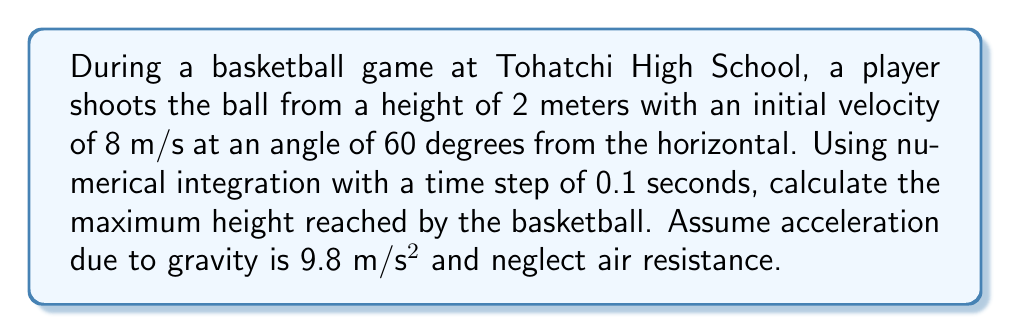Could you help me with this problem? To solve this problem, we'll use the Euler method for numerical integration. Let's break it down step-by-step:

1) First, let's define our initial conditions:
   - Initial height: $y_0 = 2$ m
   - Initial velocity in y-direction: $v_{y0} = 8 \sin(60°) = 6.93$ m/s
   - Acceleration due to gravity: $a = -9.8$ m/s²
   - Time step: $\Delta t = 0.1$ s

2) The Euler method gives us these equations:
   $y_{n+1} = y_n + v_n \Delta t$
   $v_{n+1} = v_n + a \Delta t$

3) We'll iterate until the velocity becomes negative, indicating the ball has reached its peak:

   Step 0: $t = 0$ s, $y = 2$ m, $v = 6.93$ m/s
   Step 1: $t = 0.1$ s
           $y_1 = 2 + 6.93 * 0.1 = 2.693$ m
           $v_1 = 6.93 + (-9.8) * 0.1 = 5.95$ m/s
   Step 2: $t = 0.2$ s
           $y_2 = 2.693 + 5.95 * 0.1 = 3.288$ m
           $v_2 = 5.95 + (-9.8) * 0.1 = 4.97$ m/s
   Step 3: $t = 0.3$ s
           $y_3 = 3.288 + 4.97 * 0.1 = 3.785$ m
           $v_3 = 4.97 + (-9.8) * 0.1 = 3.99$ m/s
   Step 4: $t = 0.4$ s
           $y_4 = 3.785 + 3.99 * 0.1 = 4.184$ m
           $v_4 = 3.99 + (-9.8) * 0.1 = 3.01$ m/s
   Step 5: $t = 0.5$ s
           $y_5 = 4.184 + 3.01 * 0.1 = 4.485$ m
           $v_5 = 3.01 + (-9.8) * 0.1 = 2.03$ m/s
   Step 6: $t = 0.6$ s
           $y_6 = 4.485 + 2.03 * 0.1 = 4.688$ m
           $v_6 = 2.03 + (-9.8) * 0.1 = 1.05$ m/s
   Step 7: $t = 0.7$ s
           $y_7 = 4.688 + 1.05 * 0.1 = 4.793$ m
           $v_7 = 1.05 + (-9.8) * 0.1 = 0.07$ m/s
   Step 8: $t = 0.8$ s
           $y_8 = 4.793 + 0.07 * 0.1 = 4.800$ m
           $v_8 = 0.07 + (-9.8) * 0.1 = -0.91$ m/s

4) The velocity becomes negative at step 8, so the maximum height is reached between steps 7 and 8.

5) The maximum height calculated using this numerical method is 4.800 meters.
Answer: 4.800 meters 